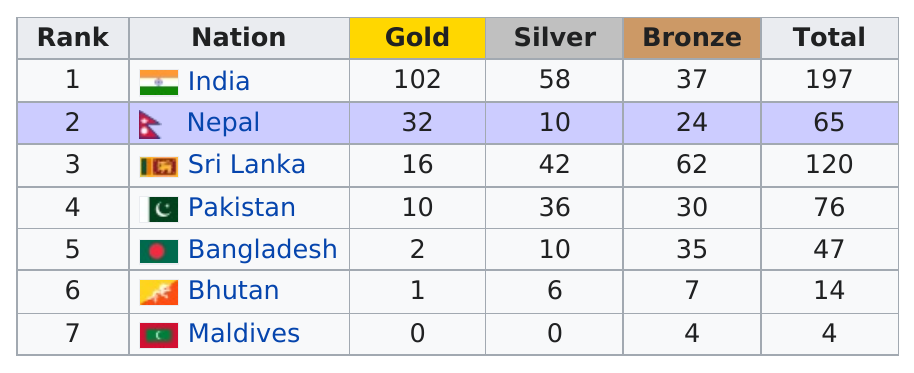Identify some key points in this picture. The country of Maldives did not receive any gold medals in the competition. Sri Lanka has won the most bronze medals. The first country on the table is India. Pakistan won a total of 36 silver medals in various sporting events. A total of 163 gold medals were awarded between all seven nations. 